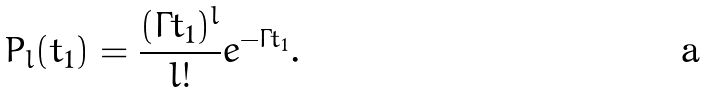<formula> <loc_0><loc_0><loc_500><loc_500>P _ { l } ( t _ { 1 } ) = \frac { ( \Gamma t _ { 1 } ) ^ { l } } { l ! } e ^ { - \Gamma t _ { 1 } } .</formula> 